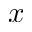Convert formula to latex. <formula><loc_0><loc_0><loc_500><loc_500>x</formula> 